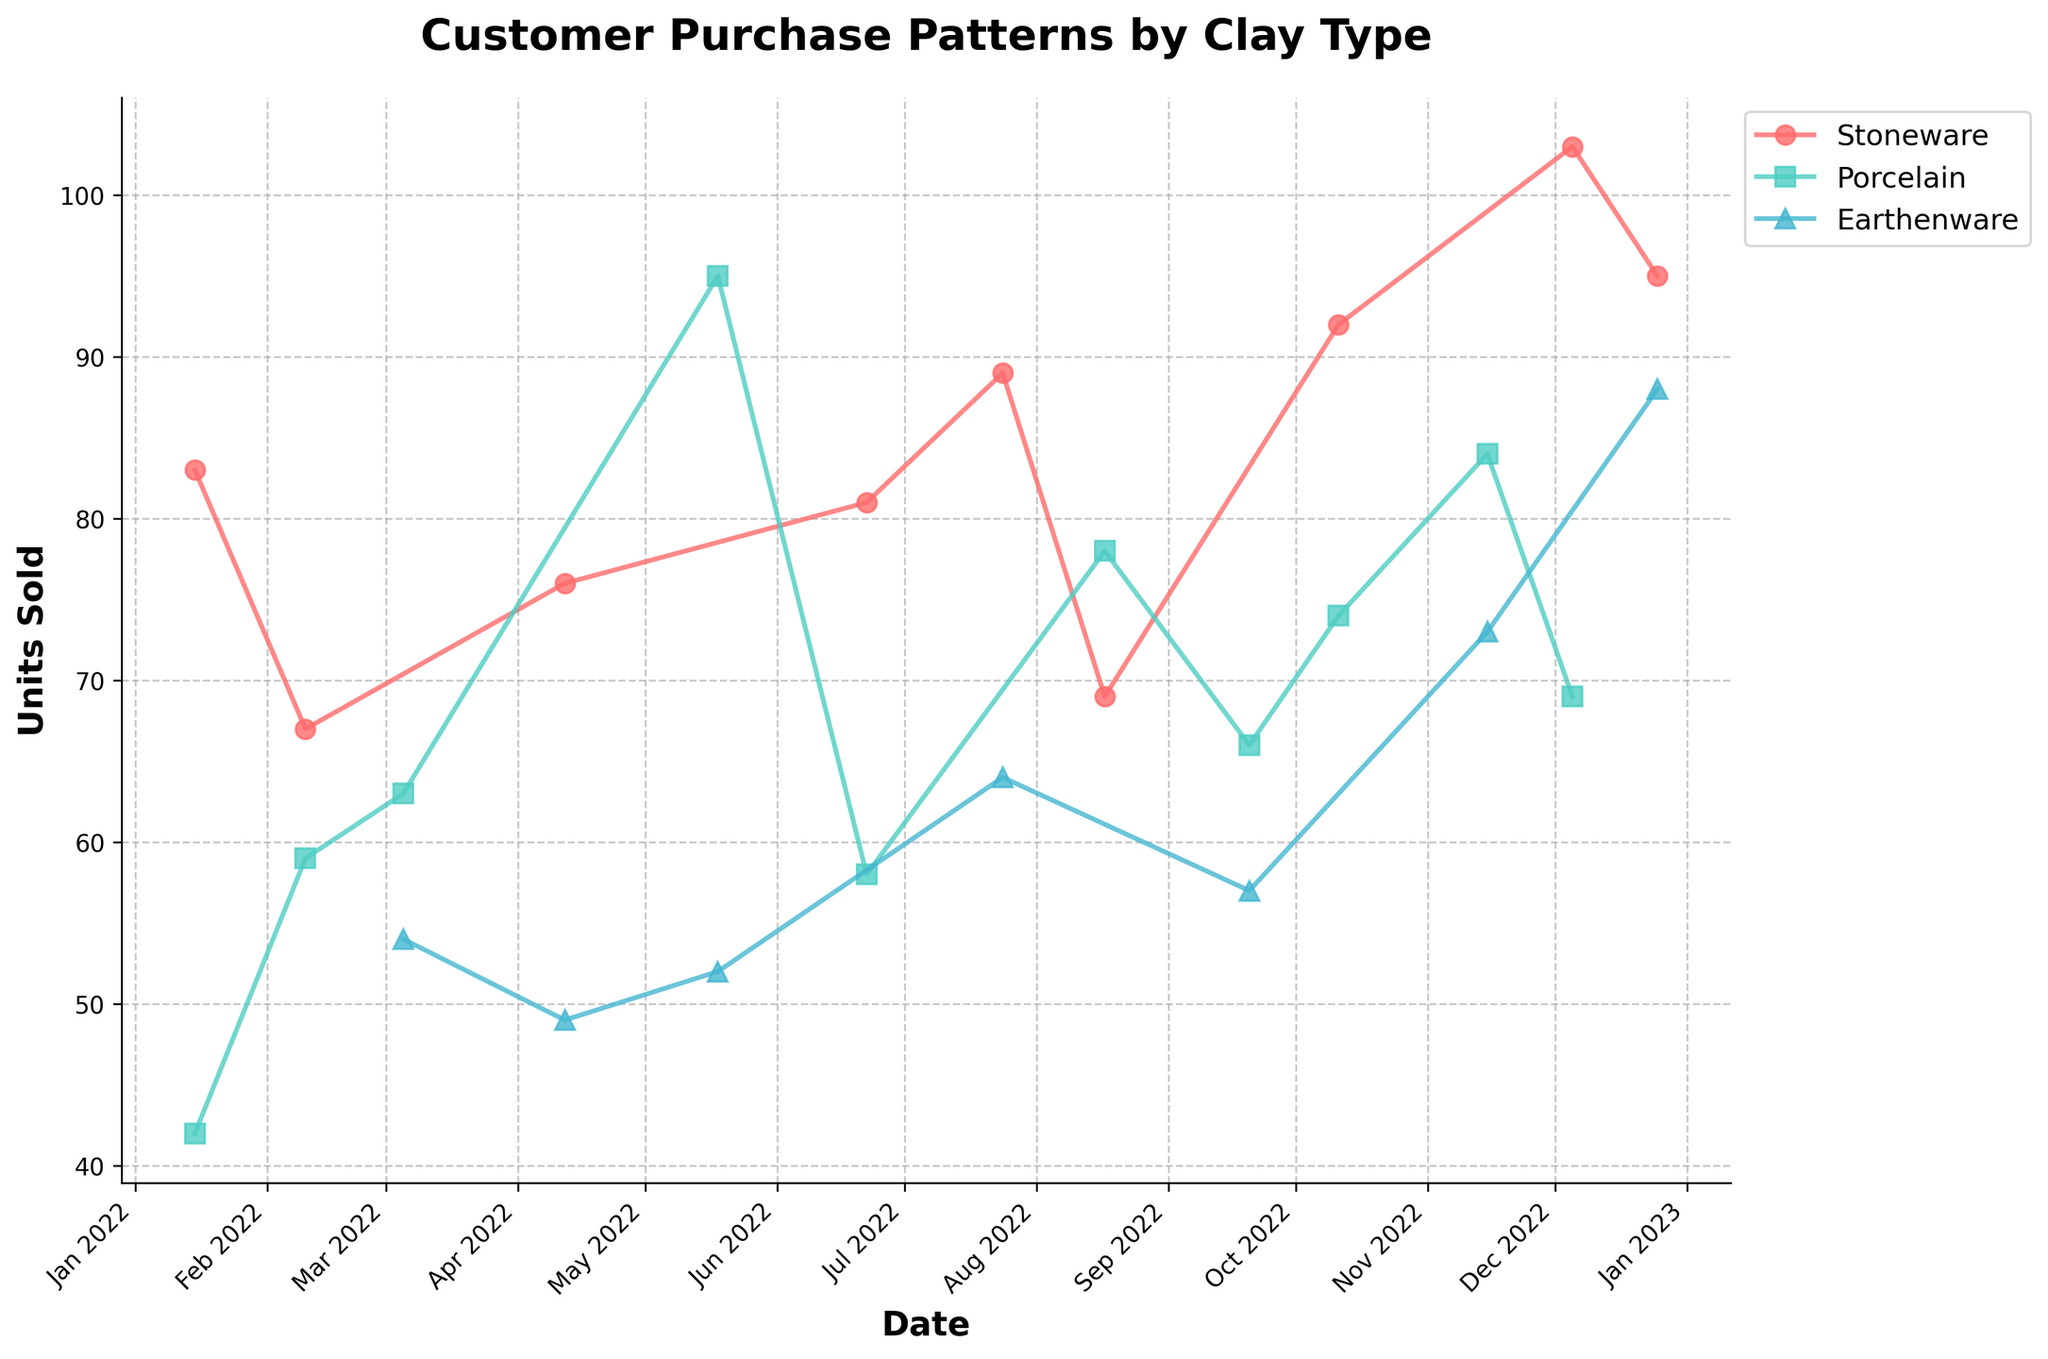What's the title of the figure? The title of the figure is shown at the top and reads "Customer Purchase Patterns by Clay Type". This gives an overview of what the plot represents.
Answer: Customer Purchase Patterns by Clay Type Which month saw the highest number of units sold for Stoneware? Look for the data points labeled "Stoneware" and identify the peak month from the x-axis (Date) and the corresponding y-axis value (Units Sold). December has the highest peak for Stoneware sales.
Answer: December How many different clay types are represented in the figure? The legend on the plot lists the different clay types represented in the figure, which are Stoneware, Porcelain, and Earthenware.
Answer: 3 What is the color used to represent Porcelain in the figure? The legend on the plot shows that Porcelain is represented by the color that matches its data points. This color is cyan.
Answer: Cyan Compare the units sold for Porcelain and Earthenware in August. Which was higher and by how much? Identify the data points for both Porcelain and Earthenware in August, marked on the x-axis. Porcelain had 78 units sold while Earthenware had none recorded. Porcelain exceeded Earthenware by 78 units.
Answer: Porcelain by 78 units During which months did Earthenware sell more units than Stoneware? Compare the data points for Earthenware and Stoneware across all months. In March, November, and December, Earthenware sold more units than Stoneware.
Answer: March, November, December Calculate the average units sold for Stoneware over the year. Sum the units sold for Stoneware across all the months and divide by the number of observations for Stoneware. (83 + 67 + 76 + 81 + 89 + 69 + 92 + 103 + 95) / 9 = 83.8
Answer: 83.8 Which season exhibited the highest aggregate sales for all clay types combined? Sum the units sold for each clay type across the months corresponding to each season (Winter: Jan-Feb-Dec, Spring: Mar-Apr-May, Summer: Jun-Jul-Aug, Fall: Sep-Oct-Nov) and compare these sums. Winter has the highest aggregate sales.
Answer: Winter Is there a month when all clay types experienced a drop in sales compared to the previous month? Examining the month-to-month trend for each clay type, identify if there is a single month where all types show a decrease in units sold from the previous month. None of the months show a simultaneous decrease across all clay types.
Answer: No What is the trend in units sold for Porcelain from May to December? Observe the Porcelain data points from May to December. The units sold show a fluctuating but generally declining trend from May (95 units) to December (69 units).
Answer: Declining trend 